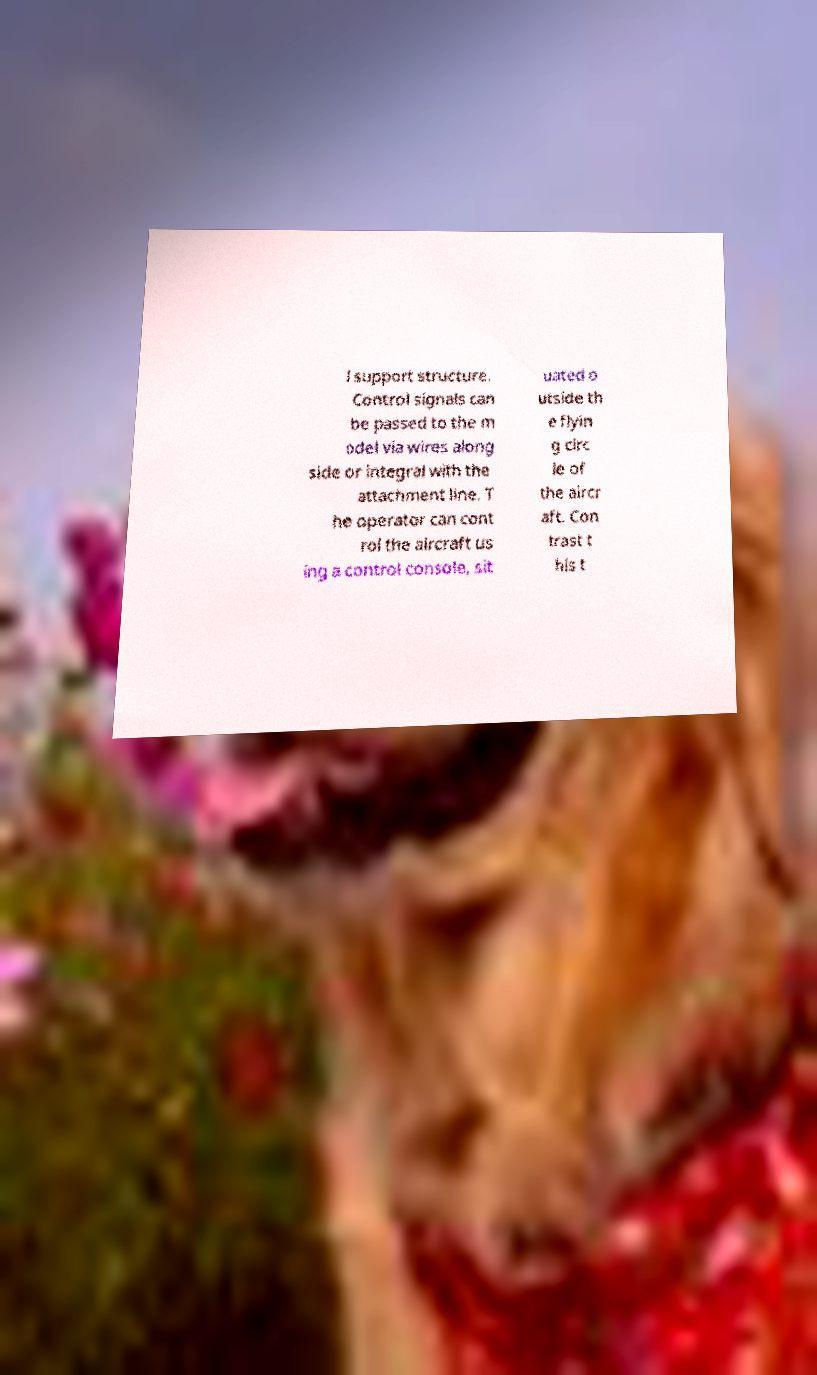For documentation purposes, I need the text within this image transcribed. Could you provide that? l support structure. Control signals can be passed to the m odel via wires along side or integral with the attachment line. T he operator can cont rol the aircraft us ing a control console, sit uated o utside th e flyin g circ le of the aircr aft. Con trast t his t 